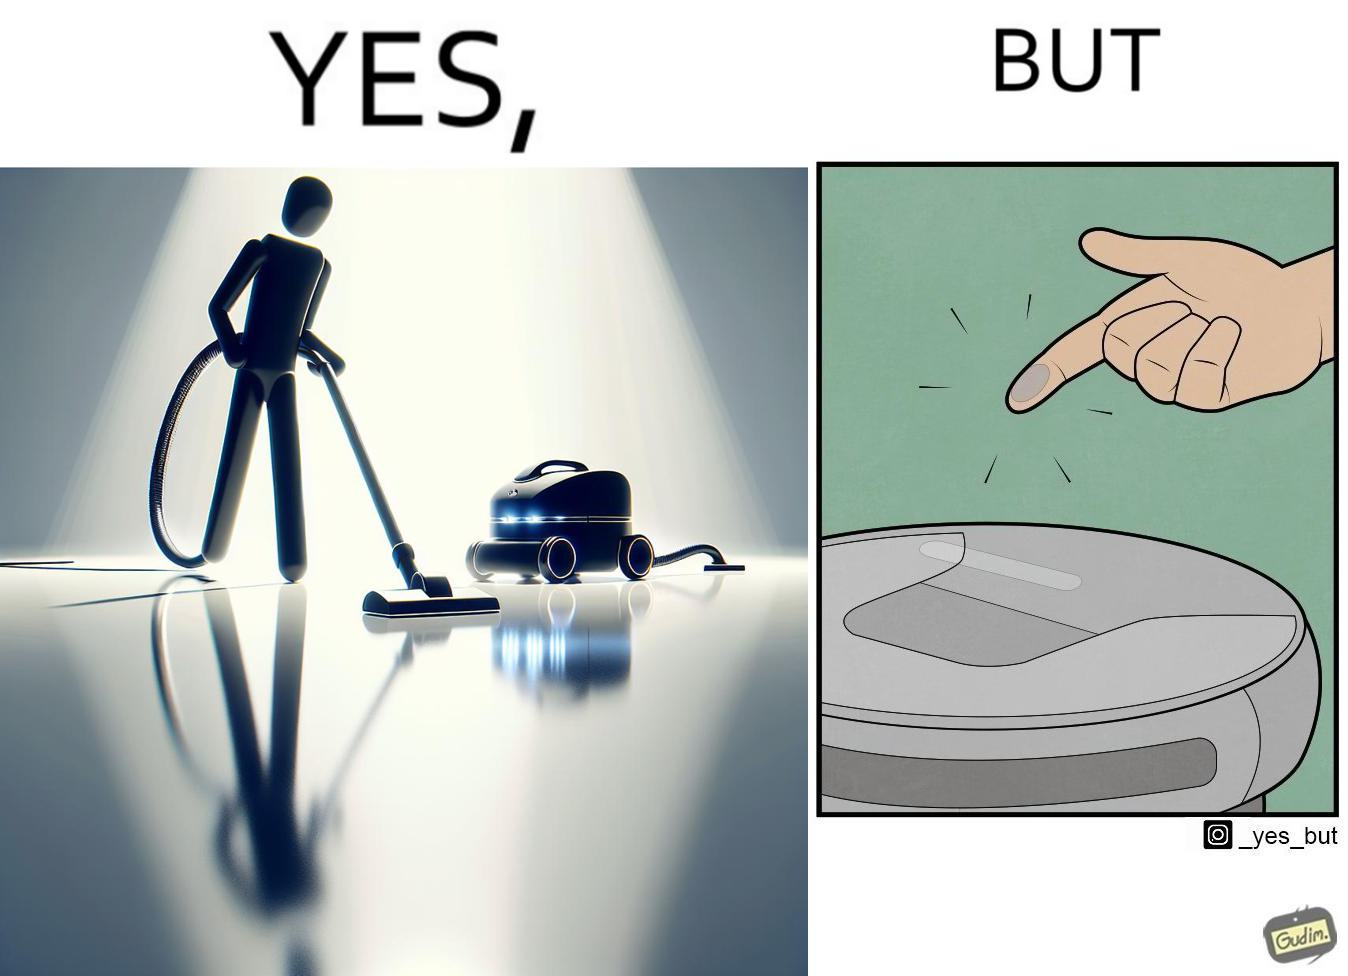Describe the contrast between the left and right parts of this image. In the left part of the image: A vacuum cleaning machine that goes around the floor on its own and cleans the floor. Everything  around it looks squeaky clean, and is shining. In the right part of the image: Close up of a vacuum cleaning machine that goes around the floor on its own and cleans the floor. Everything  around it looks squeaky clean, and is shining, but it has a lot of dust on it except one line on it that looks clean. A persons fingertip is visible, and it is covered in dust. 